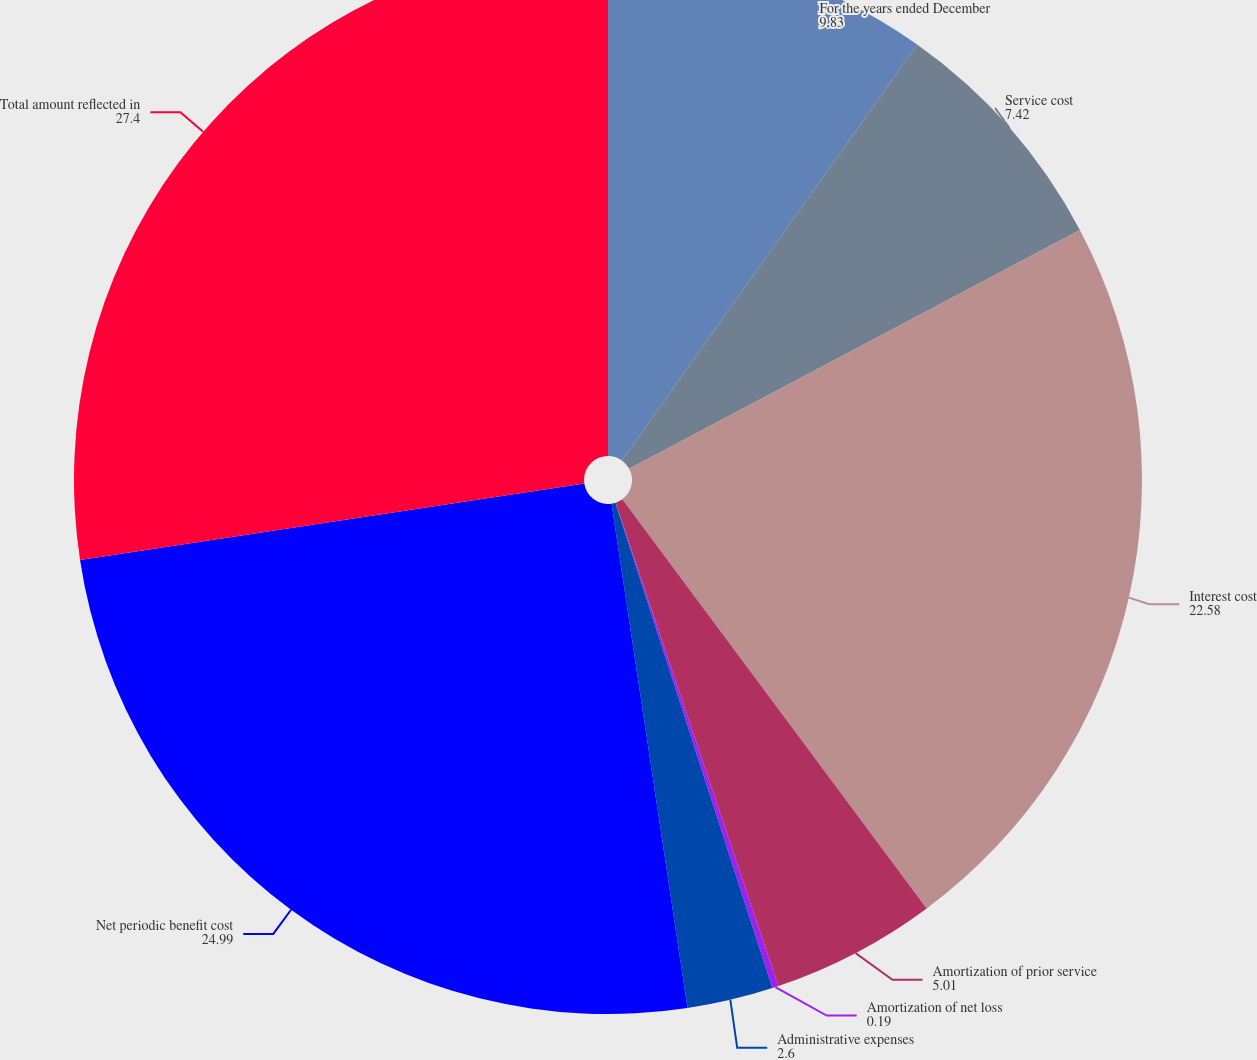Convert chart. <chart><loc_0><loc_0><loc_500><loc_500><pie_chart><fcel>For the years ended December<fcel>Service cost<fcel>Interest cost<fcel>Amortization of prior service<fcel>Amortization of net loss<fcel>Administrative expenses<fcel>Net periodic benefit cost<fcel>Total amount reflected in<nl><fcel>9.83%<fcel>7.42%<fcel>22.58%<fcel>5.01%<fcel>0.19%<fcel>2.6%<fcel>24.99%<fcel>27.4%<nl></chart> 